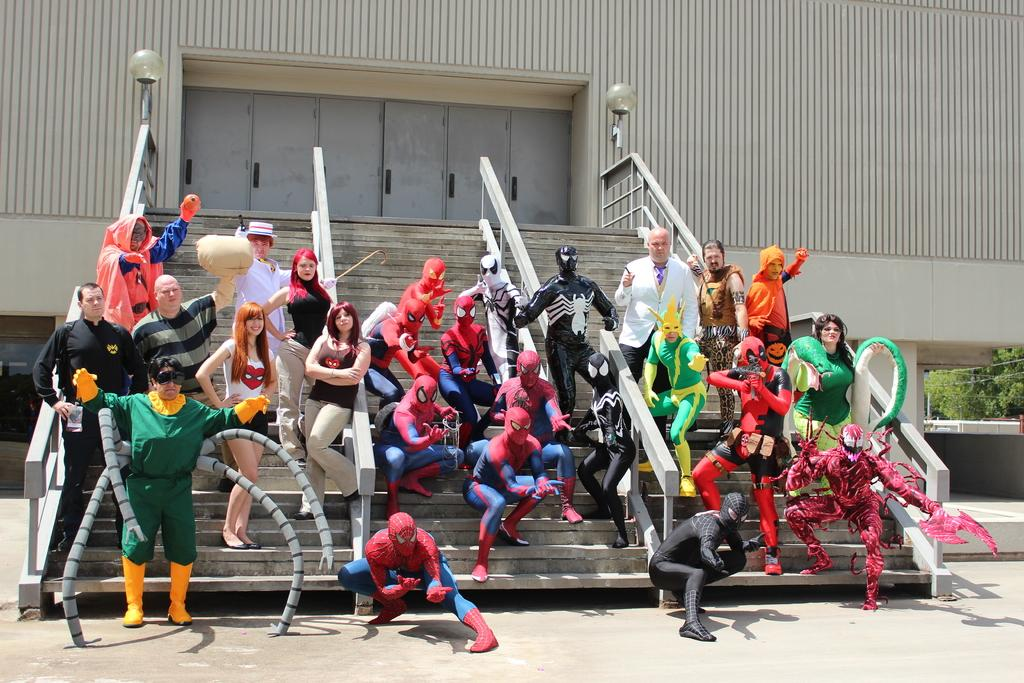How many people are in the image? There is a group of people in the image. What are the people wearing? The people are wearing fancy dresses. Where are the people standing in the image? The people are standing on stairs. What type of structure is visible in the image? There is a building in the image. What other natural elements can be seen in the image? There are trees in the image. How many cubs are playing with the sheet in the image? There are no cubs or sheets present in the image. What type of snakes can be seen slithering on the stairs in the image? There are no snakes visible in the image; the people are standing on the stairs. 